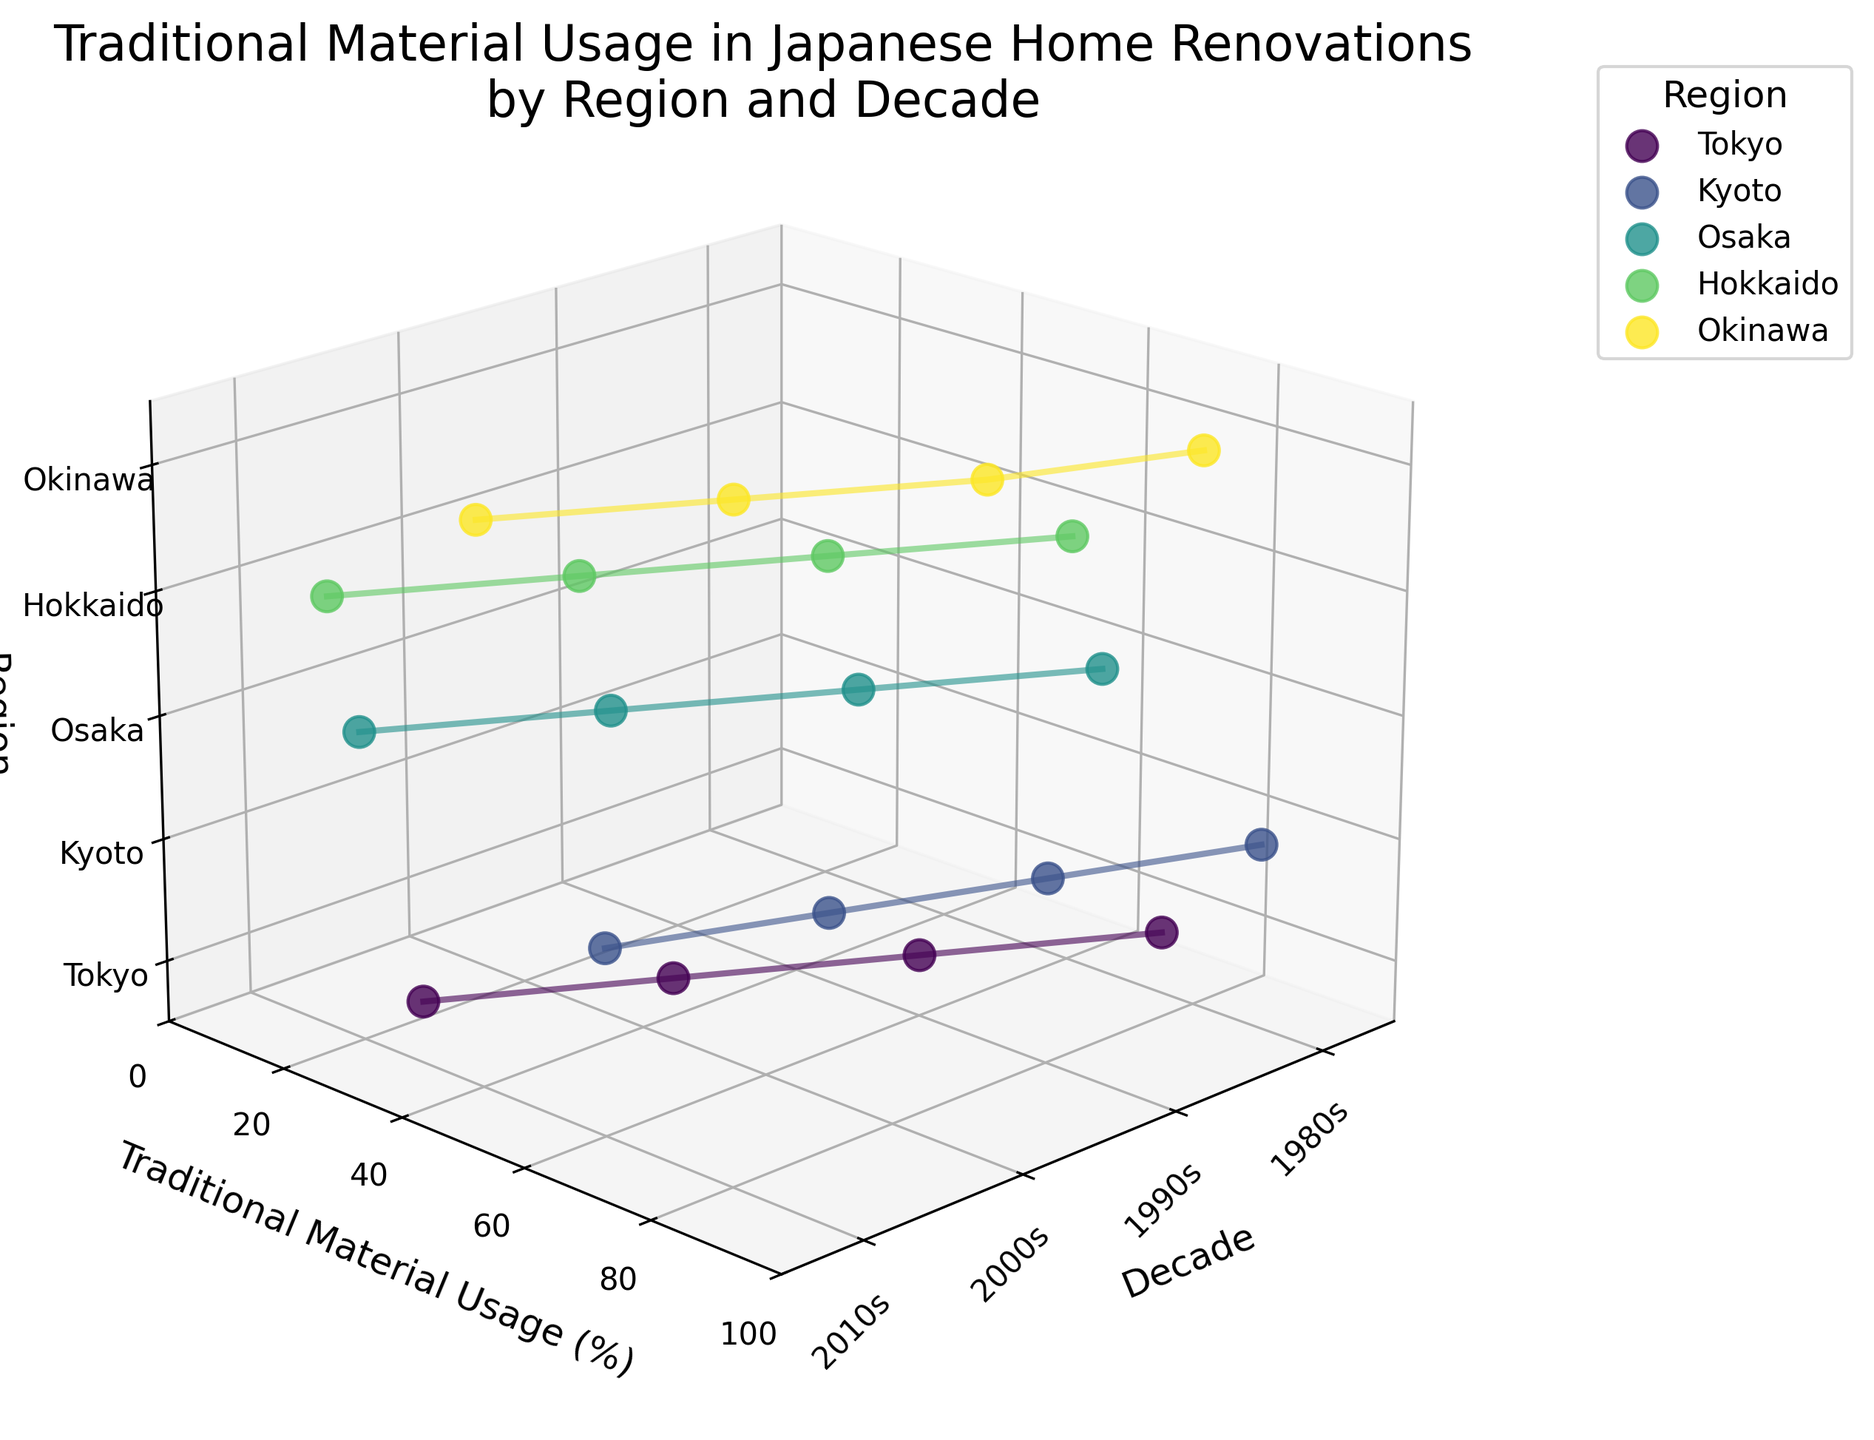What is the title of the plot? The title is positioned at the top of the plot. It reads 'Traditional Material Usage in Japanese Home Renovations by Region and Decade.'
Answer: Traditional Material Usage in Japanese Home Renovations by Region and Decade Which region has the highest traditional material usage in the 1980s? Look at the data points for the 1980s along the x-axis and observe the values on the y-axis for each region. The highest y-value in the 1980s is 90%, which corresponds to Kyoto.
Answer: Kyoto How does traditional material usage in Tokyo change from the 1980s to the 2010s? Examine the trend for Tokyo by following its line from the point in the 1980s to the 2010s. Traditional material usage decreases from 75% in the 1980s to 30% in the 2010s.
Answer: It decreases from 75% to 30% What is the average traditional material usage for Kyoto across all decades? Sum the traditional material usage percentages for Kyoto and then divide by the number of decades. The calculations are (90 + 80 + 70 + 60) / 4.
Answer: 75% Which region shows the most significant decrease in traditional material usage over the decades? Compare the trends for each region by observing the difference between the 1980s and 2010s. Hokkaido shows the most significant decrease, with traditional material usage dropping from 60% to 15%.
Answer: Hokkaido How does the traditional material usage in Hokkaido's bathrooms compare to Okinawa's bedrooms in the 2010s? Identify the traditional material usage for both regions in the 2010s. Hokkaido's bathroom has 15%, while Okinawa's bedroom has 40%.
Answer: Hokkaido's bathroom has less usage Which region has the lowest traditional material usage in the 2010s? Identify the data points for the 2010s and find the lowest value on the y-axis. Hokkaido has the lowest traditional material usage at 15% in the 2010s.
Answer: Hokkaido What is the pattern of traditional material usage in Osaka's kitchens over the years? Track the changes in traditional material usage in Osaka from the 1980s to the 2010s. It decreases from 65% to 20%.
Answer: It decreases from 65% to 20% Compare the traditional material usage in Kyoto and Tokyo in the 1990s. Which is higher? Look at the traditional material usage values for both regions in the 1990s. Kyoto has 80%, while Tokyo has 60%.
Answer: Kyoto has higher usage What is the range of traditional material usage in the data? Find the minimum and maximum values across all regions and decades. The minimum is 15% (Hokkaido in the 2010s), and the maximum is 90% (Kyoto in the 1980s). The range is 90% - 15% = 75%.
Answer: 75% 